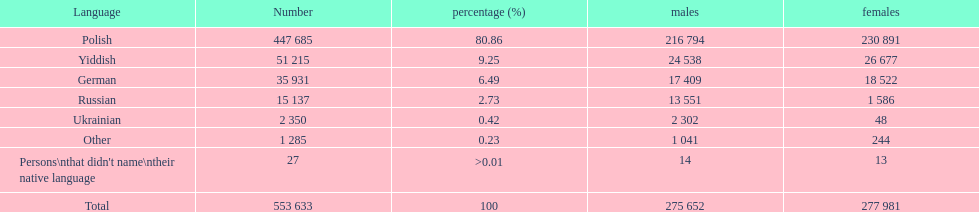During the imperial census of 1897, which language was most prevalent among the population in the płock governorate? Polish. 